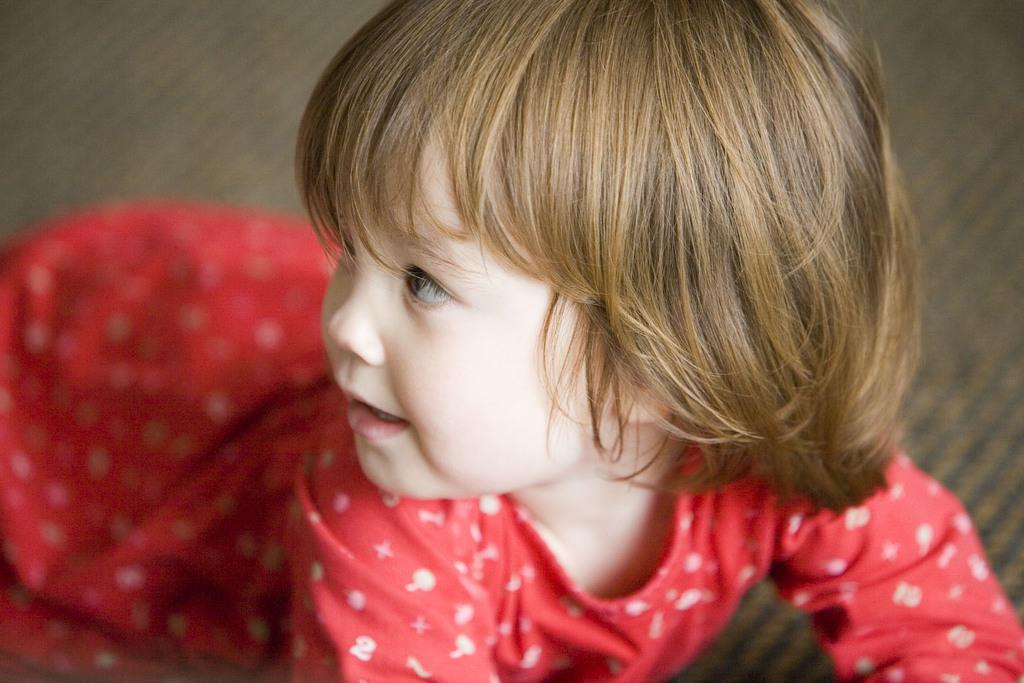What is the position of the kid in the image? There is a kid sitting on the floor in the image. What type of glue is the kid using in the image? There is no glue present in the image; the kid is simply sitting on the floor. What is the kid's desire in the image? The image does not provide information about the kid's desires or emotions. 